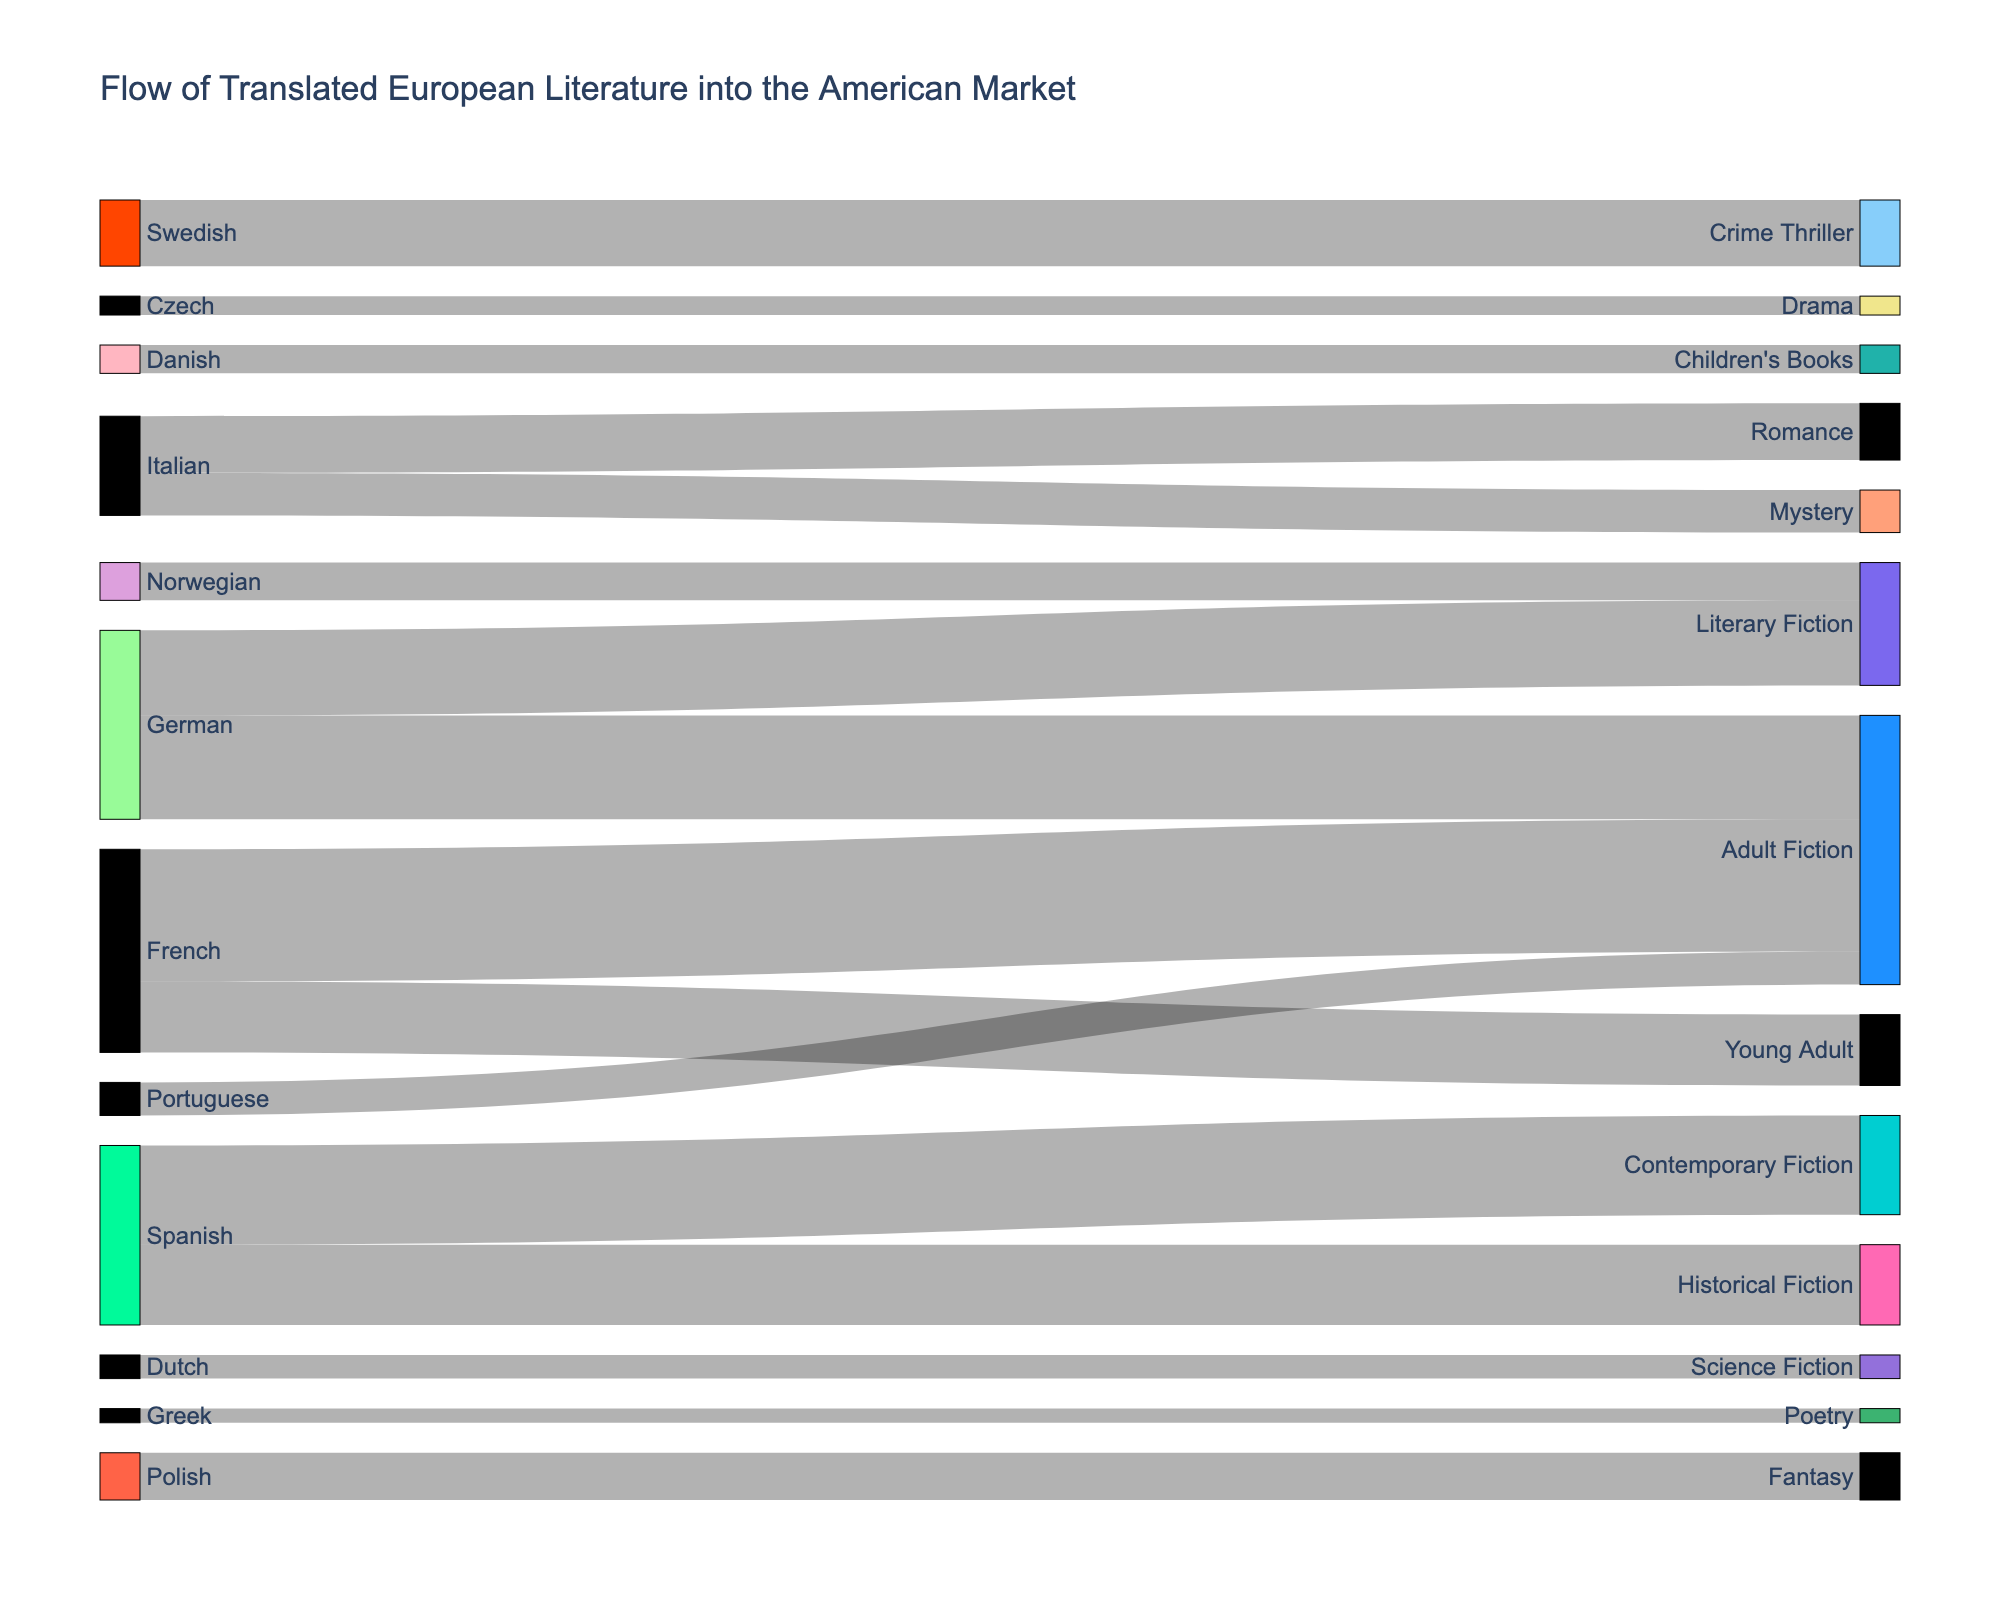What is the title of the diagram? The title of the diagram is displayed at the top of the figure. It reads "Flow of Translated European Literature into the American Market."
Answer: Flow of Translated European Literature into the American Market Which source language has the highest total translated volume? By comparing the values associated with each source language, French has the highest total with 150,000 (Young Adult) + 280,000 (Adult Fiction) = 430,000.
Answer: French What is the total number of translated books for Adult Fiction? To find the total, sum the values from all source languages targeting Adult Fiction: 280,000 (French) + 220,000 (German) + 70,000 (Portuguese) = 570,000.
Answer: 570,000 Which target demographic receives translations from the most number of source languages? By counting the distinct source languages converging into each target demographic, Adult Fiction (French, German, Portuguese) and Literary Fiction (German, Norwegian) appear to have the most, but Adult Fiction has translations from three different languages.
Answer: Adult Fiction What is the least popular target demographic in terms of total translated volume? Summing the values for each target demographic and comparing them, the least popular one is Poetry with only 30,000 translated books from Greek.
Answer: Poetry How many books are translated from German into literary genres? Summing the values of books translated from German into literary genres: Adult Fiction (220,000) and Literary Fiction (180,000). The total is 220,000 + 180,000 = 400,000.
Answer: 400,000 Compare the total translations from Scandinavian languages (Swedish, Norwegian, Danish). Which one has the highest volume? Add the values for each Scandinavian language: Swedish (140,000), Norwegian (80,000), Danish (60,000). The highest is from Swedish with 140,000.
Answer: Swedish What percentage of the total translated books is dedicated to Crime Thriller? First find the total value for all books: sum all values (150,000 + 280,000 + 220,000 + 180,000 + 120,000 + 90,000 + 170,000 + 210,000 + 140,000 + 80,000 + 60,000 + 50,000 + 70,000 + 30,000 + 100,000 + 40,000). Then, find the percentage for Crime Thriller by dividing its value (140,000) by the total and multiplying by 100: (140,000 / 1,990,000) * 100 ≈ 7.04%.
Answer: 7.04% Which language contributes to Children's Books translation and what is its volume? By examining the target demographic of Children's Books, it is translated from Danish with a value of 60,000.
Answer: Danish, 60,000 How does the volume of translated Historical Fiction compare to Crime Thriller? Historical Fiction has translations from Spanish with a value of 170,000, while Crime Thriller has 140,000 from Swedish. Comparing these values, Historical Fiction (170,000) is more than Crime Thriller (140,000).
Answer: Historical Fiction is more 